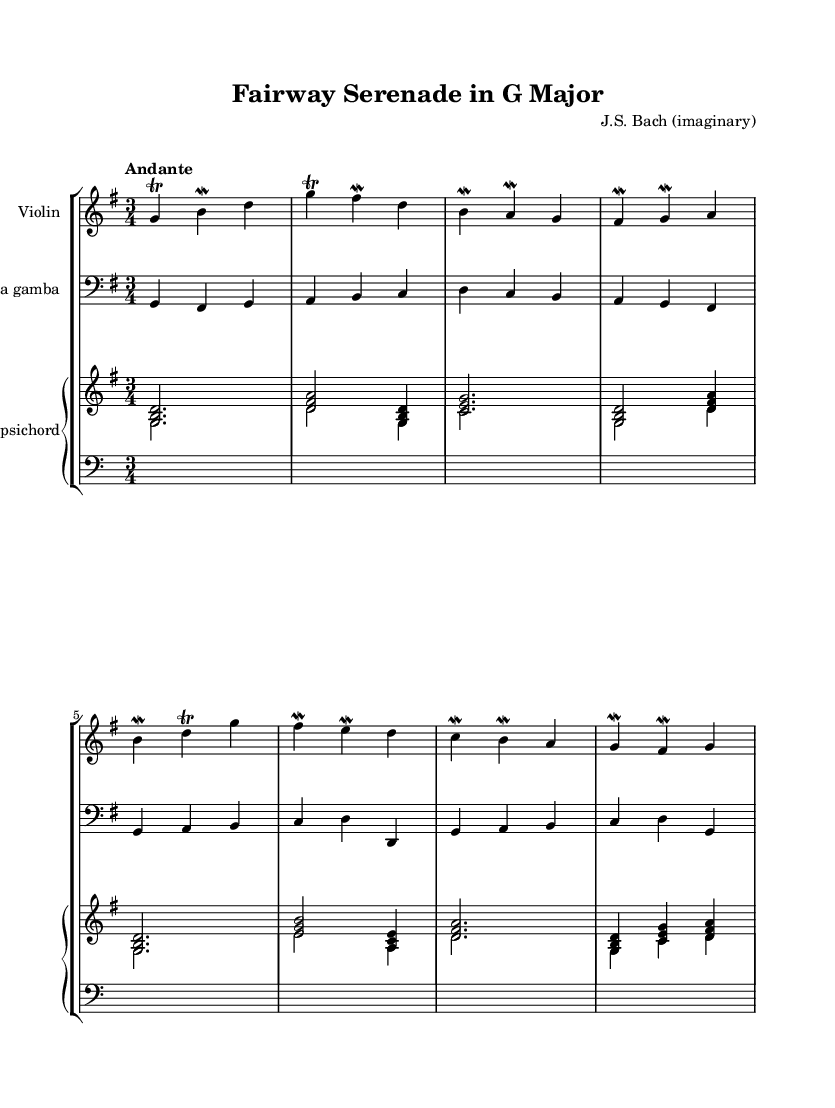What is the key signature of this music? The key signature is G major, which has one sharp (F sharp). This can be identified at the beginning of the staff where the key signature is indicated.
Answer: G major What is the time signature of the piece? The time signature is 3/4, which means there are three beats per measure and the quarter note receives one beat. This is noted next to the key signature at the start of the piece.
Answer: 3/4 What is the tempo marking of this composition? The tempo marking is "Andante," indicating a moderate pace. This marking is typically found above the staff at the start of the piece, guiding the performance speed.
Answer: Andante How many instruments are in this chamber music composition? There are three different instruments: violin, viola da gamba, and harpsichord. This can be determined by the presence of three distinct staves labeled for each instrument arrangement.
Answer: Three Which voice provides the harmonic support in this score? The harpsichord provides the harmonic support as it plays chords and bass lines, while the other instruments play the melody. The presence of piano staff specifically indicates harmony.
Answer: Harpsichord What type of ornamentation is frequently used in the violin part? The violin part frequently uses trills and mordents. These decorative elements can be identified by specific symbols written above or next to the notes throughout the violin staff.
Answer: Trills and mordents What characteristic of Baroque music is illustrated by the use of figured bass in this piece? The characteristic is the improvisational aspect, allowing performers to create harmonies on the spot based on the written bass line. The lower staff indicates this figured bass format, typical in Baroque compositions.
Answer: Improvisational aspect 